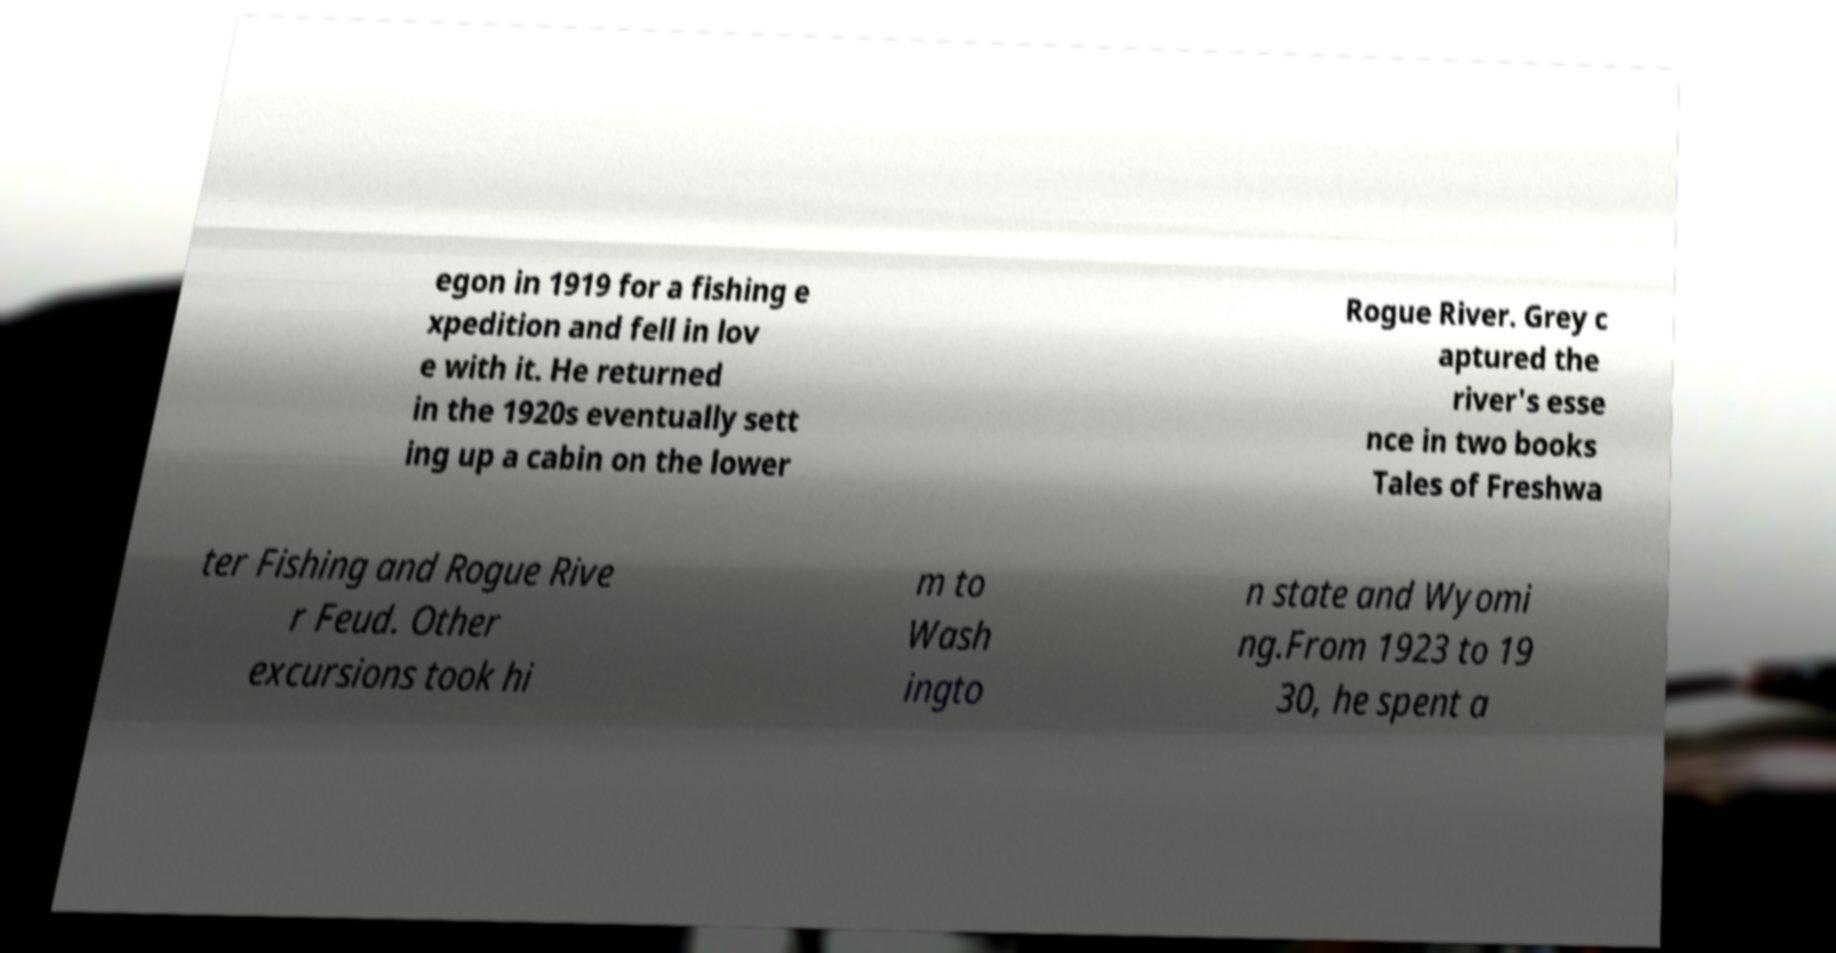Can you read and provide the text displayed in the image?This photo seems to have some interesting text. Can you extract and type it out for me? egon in 1919 for a fishing e xpedition and fell in lov e with it. He returned in the 1920s eventually sett ing up a cabin on the lower Rogue River. Grey c aptured the river's esse nce in two books Tales of Freshwa ter Fishing and Rogue Rive r Feud. Other excursions took hi m to Wash ingto n state and Wyomi ng.From 1923 to 19 30, he spent a 